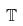<formula> <loc_0><loc_0><loc_500><loc_500>\mathbb { T }</formula> 